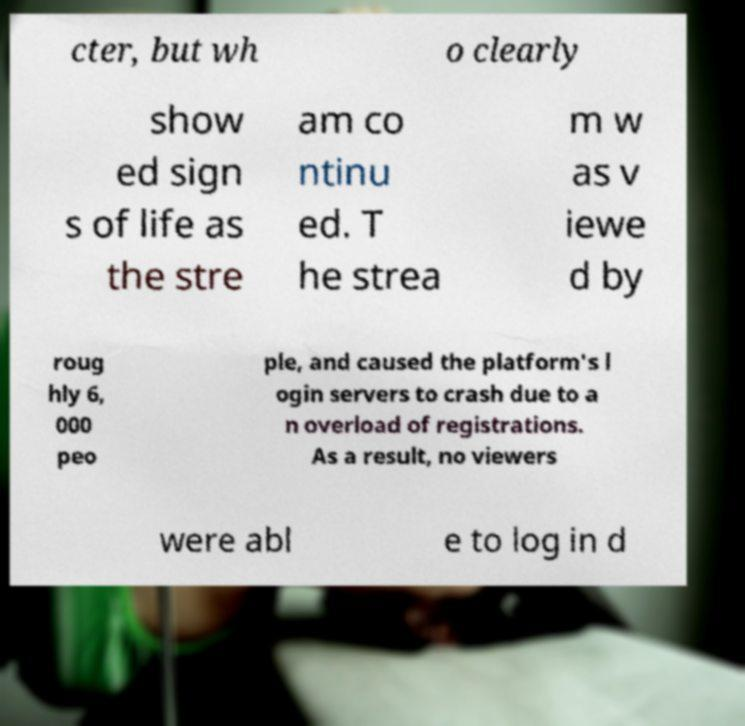For documentation purposes, I need the text within this image transcribed. Could you provide that? cter, but wh o clearly show ed sign s of life as the stre am co ntinu ed. T he strea m w as v iewe d by roug hly 6, 000 peo ple, and caused the platform's l ogin servers to crash due to a n overload of registrations. As a result, no viewers were abl e to log in d 